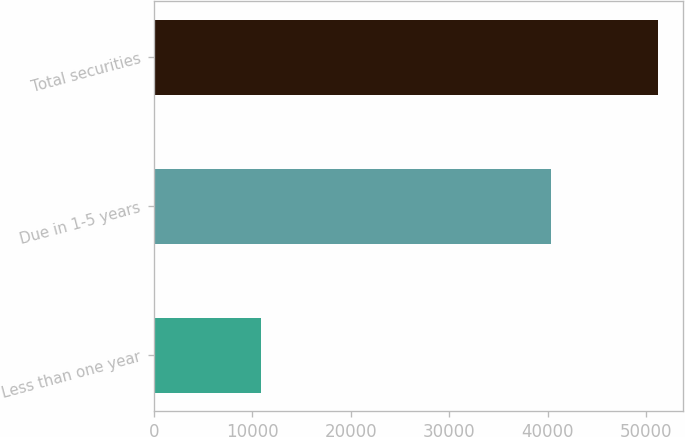Convert chart. <chart><loc_0><loc_0><loc_500><loc_500><bar_chart><fcel>Less than one year<fcel>Due in 1-5 years<fcel>Total securities<nl><fcel>10870<fcel>40338<fcel>51208<nl></chart> 